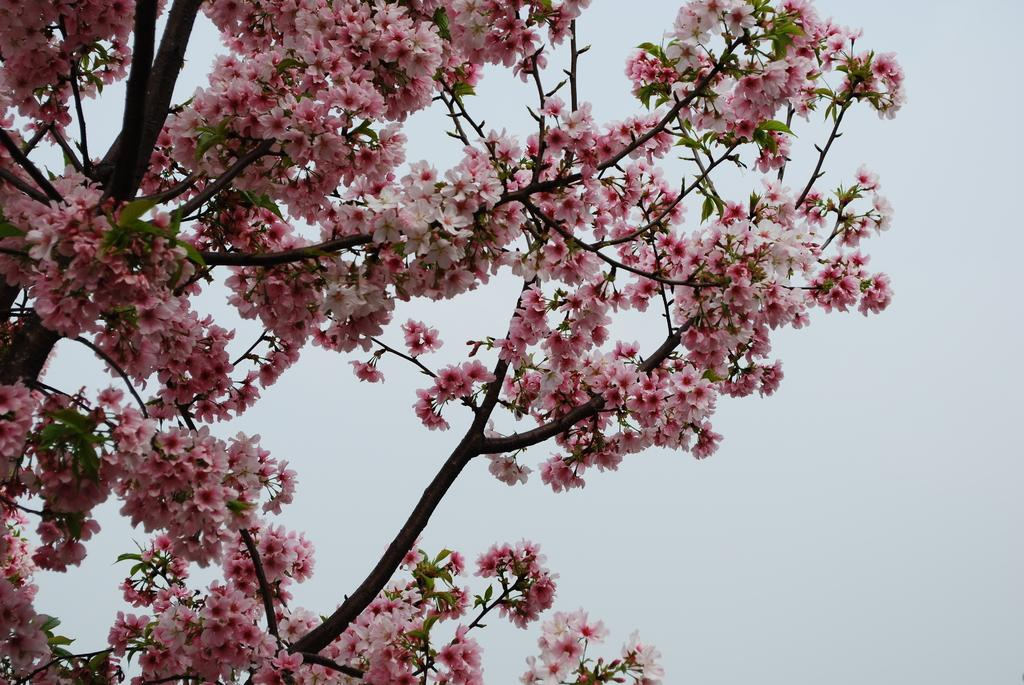What type of vegetation can be seen on the tree in the image? There are flowers on the tree in the image. What colors are the flowers? The flowers are pink and white in color. What type of tank can be seen in the image? There is no tank present in the image; it features a tree with pink and white flowers. Can you describe the airplane in the image? There is no airplane present in the image; it features a tree with pink and white flowers. 